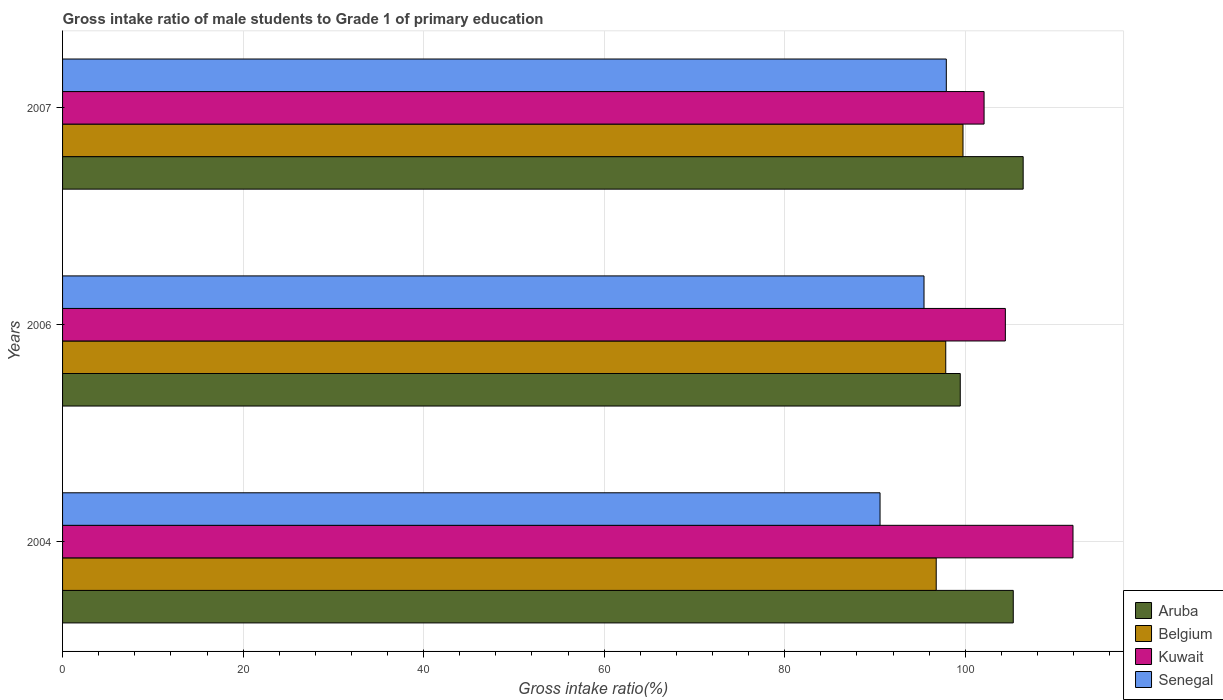How many different coloured bars are there?
Provide a short and direct response. 4. How many groups of bars are there?
Keep it short and to the point. 3. How many bars are there on the 3rd tick from the bottom?
Provide a succinct answer. 4. What is the gross intake ratio in Senegal in 2007?
Your response must be concise. 97.9. Across all years, what is the maximum gross intake ratio in Aruba?
Offer a very short reply. 106.42. Across all years, what is the minimum gross intake ratio in Kuwait?
Give a very brief answer. 102.08. In which year was the gross intake ratio in Senegal minimum?
Your answer should be very brief. 2004. What is the total gross intake ratio in Aruba in the graph?
Provide a short and direct response. 311.18. What is the difference between the gross intake ratio in Senegal in 2004 and that in 2006?
Keep it short and to the point. -4.87. What is the difference between the gross intake ratio in Aruba in 2004 and the gross intake ratio in Belgium in 2006?
Give a very brief answer. 7.48. What is the average gross intake ratio in Senegal per year?
Provide a short and direct response. 94.63. In the year 2007, what is the difference between the gross intake ratio in Kuwait and gross intake ratio in Aruba?
Your response must be concise. -4.33. In how many years, is the gross intake ratio in Aruba greater than 112 %?
Ensure brevity in your answer.  0. What is the ratio of the gross intake ratio in Kuwait in 2006 to that in 2007?
Provide a short and direct response. 1.02. Is the gross intake ratio in Aruba in 2006 less than that in 2007?
Your answer should be compact. Yes. Is the difference between the gross intake ratio in Kuwait in 2004 and 2007 greater than the difference between the gross intake ratio in Aruba in 2004 and 2007?
Keep it short and to the point. Yes. What is the difference between the highest and the second highest gross intake ratio in Senegal?
Keep it short and to the point. 2.47. What is the difference between the highest and the lowest gross intake ratio in Belgium?
Your response must be concise. 2.97. In how many years, is the gross intake ratio in Aruba greater than the average gross intake ratio in Aruba taken over all years?
Your answer should be compact. 2. Is the sum of the gross intake ratio in Kuwait in 2004 and 2006 greater than the maximum gross intake ratio in Belgium across all years?
Your answer should be compact. Yes. What does the 1st bar from the top in 2007 represents?
Your answer should be compact. Senegal. What does the 4th bar from the bottom in 2006 represents?
Keep it short and to the point. Senegal. How many legend labels are there?
Keep it short and to the point. 4. What is the title of the graph?
Your answer should be very brief. Gross intake ratio of male students to Grade 1 of primary education. Does "Latin America(developing only)" appear as one of the legend labels in the graph?
Ensure brevity in your answer.  No. What is the label or title of the X-axis?
Your answer should be compact. Gross intake ratio(%). What is the label or title of the Y-axis?
Offer a very short reply. Years. What is the Gross intake ratio(%) in Aruba in 2004?
Keep it short and to the point. 105.32. What is the Gross intake ratio(%) of Belgium in 2004?
Your response must be concise. 96.78. What is the Gross intake ratio(%) of Kuwait in 2004?
Provide a short and direct response. 111.94. What is the Gross intake ratio(%) in Senegal in 2004?
Keep it short and to the point. 90.56. What is the Gross intake ratio(%) in Aruba in 2006?
Make the answer very short. 99.45. What is the Gross intake ratio(%) of Belgium in 2006?
Provide a short and direct response. 97.84. What is the Gross intake ratio(%) in Kuwait in 2006?
Ensure brevity in your answer.  104.44. What is the Gross intake ratio(%) of Senegal in 2006?
Your answer should be very brief. 95.43. What is the Gross intake ratio(%) in Aruba in 2007?
Ensure brevity in your answer.  106.42. What is the Gross intake ratio(%) in Belgium in 2007?
Make the answer very short. 99.75. What is the Gross intake ratio(%) in Kuwait in 2007?
Make the answer very short. 102.08. What is the Gross intake ratio(%) in Senegal in 2007?
Your answer should be very brief. 97.9. Across all years, what is the maximum Gross intake ratio(%) in Aruba?
Your answer should be compact. 106.42. Across all years, what is the maximum Gross intake ratio(%) in Belgium?
Make the answer very short. 99.75. Across all years, what is the maximum Gross intake ratio(%) in Kuwait?
Provide a short and direct response. 111.94. Across all years, what is the maximum Gross intake ratio(%) of Senegal?
Offer a terse response. 97.9. Across all years, what is the minimum Gross intake ratio(%) in Aruba?
Make the answer very short. 99.45. Across all years, what is the minimum Gross intake ratio(%) in Belgium?
Offer a terse response. 96.78. Across all years, what is the minimum Gross intake ratio(%) of Kuwait?
Keep it short and to the point. 102.08. Across all years, what is the minimum Gross intake ratio(%) in Senegal?
Keep it short and to the point. 90.56. What is the total Gross intake ratio(%) in Aruba in the graph?
Make the answer very short. 311.18. What is the total Gross intake ratio(%) of Belgium in the graph?
Provide a short and direct response. 294.37. What is the total Gross intake ratio(%) in Kuwait in the graph?
Your response must be concise. 318.46. What is the total Gross intake ratio(%) in Senegal in the graph?
Provide a succinct answer. 283.89. What is the difference between the Gross intake ratio(%) of Aruba in 2004 and that in 2006?
Your answer should be compact. 5.87. What is the difference between the Gross intake ratio(%) in Belgium in 2004 and that in 2006?
Make the answer very short. -1.06. What is the difference between the Gross intake ratio(%) in Kuwait in 2004 and that in 2006?
Offer a terse response. 7.49. What is the difference between the Gross intake ratio(%) in Senegal in 2004 and that in 2006?
Ensure brevity in your answer.  -4.87. What is the difference between the Gross intake ratio(%) in Aruba in 2004 and that in 2007?
Offer a very short reply. -1.1. What is the difference between the Gross intake ratio(%) in Belgium in 2004 and that in 2007?
Provide a succinct answer. -2.97. What is the difference between the Gross intake ratio(%) in Kuwait in 2004 and that in 2007?
Offer a terse response. 9.85. What is the difference between the Gross intake ratio(%) in Senegal in 2004 and that in 2007?
Provide a short and direct response. -7.34. What is the difference between the Gross intake ratio(%) of Aruba in 2006 and that in 2007?
Provide a short and direct response. -6.97. What is the difference between the Gross intake ratio(%) in Belgium in 2006 and that in 2007?
Provide a short and direct response. -1.91. What is the difference between the Gross intake ratio(%) of Kuwait in 2006 and that in 2007?
Provide a succinct answer. 2.36. What is the difference between the Gross intake ratio(%) of Senegal in 2006 and that in 2007?
Make the answer very short. -2.47. What is the difference between the Gross intake ratio(%) in Aruba in 2004 and the Gross intake ratio(%) in Belgium in 2006?
Make the answer very short. 7.48. What is the difference between the Gross intake ratio(%) of Aruba in 2004 and the Gross intake ratio(%) of Kuwait in 2006?
Keep it short and to the point. 0.88. What is the difference between the Gross intake ratio(%) of Aruba in 2004 and the Gross intake ratio(%) of Senegal in 2006?
Provide a succinct answer. 9.89. What is the difference between the Gross intake ratio(%) in Belgium in 2004 and the Gross intake ratio(%) in Kuwait in 2006?
Offer a terse response. -7.66. What is the difference between the Gross intake ratio(%) in Belgium in 2004 and the Gross intake ratio(%) in Senegal in 2006?
Keep it short and to the point. 1.35. What is the difference between the Gross intake ratio(%) of Kuwait in 2004 and the Gross intake ratio(%) of Senegal in 2006?
Give a very brief answer. 16.51. What is the difference between the Gross intake ratio(%) of Aruba in 2004 and the Gross intake ratio(%) of Belgium in 2007?
Provide a succinct answer. 5.57. What is the difference between the Gross intake ratio(%) in Aruba in 2004 and the Gross intake ratio(%) in Kuwait in 2007?
Offer a terse response. 3.23. What is the difference between the Gross intake ratio(%) of Aruba in 2004 and the Gross intake ratio(%) of Senegal in 2007?
Your answer should be compact. 7.42. What is the difference between the Gross intake ratio(%) in Belgium in 2004 and the Gross intake ratio(%) in Kuwait in 2007?
Your answer should be very brief. -5.3. What is the difference between the Gross intake ratio(%) in Belgium in 2004 and the Gross intake ratio(%) in Senegal in 2007?
Your response must be concise. -1.12. What is the difference between the Gross intake ratio(%) of Kuwait in 2004 and the Gross intake ratio(%) of Senegal in 2007?
Ensure brevity in your answer.  14.03. What is the difference between the Gross intake ratio(%) in Aruba in 2006 and the Gross intake ratio(%) in Belgium in 2007?
Your response must be concise. -0.3. What is the difference between the Gross intake ratio(%) in Aruba in 2006 and the Gross intake ratio(%) in Kuwait in 2007?
Your response must be concise. -2.64. What is the difference between the Gross intake ratio(%) of Aruba in 2006 and the Gross intake ratio(%) of Senegal in 2007?
Ensure brevity in your answer.  1.55. What is the difference between the Gross intake ratio(%) in Belgium in 2006 and the Gross intake ratio(%) in Kuwait in 2007?
Your answer should be compact. -4.24. What is the difference between the Gross intake ratio(%) of Belgium in 2006 and the Gross intake ratio(%) of Senegal in 2007?
Provide a succinct answer. -0.06. What is the difference between the Gross intake ratio(%) in Kuwait in 2006 and the Gross intake ratio(%) in Senegal in 2007?
Provide a short and direct response. 6.54. What is the average Gross intake ratio(%) of Aruba per year?
Keep it short and to the point. 103.73. What is the average Gross intake ratio(%) in Belgium per year?
Offer a very short reply. 98.12. What is the average Gross intake ratio(%) in Kuwait per year?
Keep it short and to the point. 106.15. What is the average Gross intake ratio(%) in Senegal per year?
Offer a terse response. 94.63. In the year 2004, what is the difference between the Gross intake ratio(%) of Aruba and Gross intake ratio(%) of Belgium?
Keep it short and to the point. 8.54. In the year 2004, what is the difference between the Gross intake ratio(%) of Aruba and Gross intake ratio(%) of Kuwait?
Ensure brevity in your answer.  -6.62. In the year 2004, what is the difference between the Gross intake ratio(%) of Aruba and Gross intake ratio(%) of Senegal?
Ensure brevity in your answer.  14.76. In the year 2004, what is the difference between the Gross intake ratio(%) of Belgium and Gross intake ratio(%) of Kuwait?
Your response must be concise. -15.15. In the year 2004, what is the difference between the Gross intake ratio(%) in Belgium and Gross intake ratio(%) in Senegal?
Give a very brief answer. 6.22. In the year 2004, what is the difference between the Gross intake ratio(%) of Kuwait and Gross intake ratio(%) of Senegal?
Provide a short and direct response. 21.38. In the year 2006, what is the difference between the Gross intake ratio(%) of Aruba and Gross intake ratio(%) of Belgium?
Provide a short and direct response. 1.61. In the year 2006, what is the difference between the Gross intake ratio(%) of Aruba and Gross intake ratio(%) of Kuwait?
Offer a very short reply. -5. In the year 2006, what is the difference between the Gross intake ratio(%) in Aruba and Gross intake ratio(%) in Senegal?
Ensure brevity in your answer.  4.02. In the year 2006, what is the difference between the Gross intake ratio(%) in Belgium and Gross intake ratio(%) in Kuwait?
Provide a succinct answer. -6.6. In the year 2006, what is the difference between the Gross intake ratio(%) of Belgium and Gross intake ratio(%) of Senegal?
Provide a short and direct response. 2.41. In the year 2006, what is the difference between the Gross intake ratio(%) in Kuwait and Gross intake ratio(%) in Senegal?
Provide a succinct answer. 9.01. In the year 2007, what is the difference between the Gross intake ratio(%) of Aruba and Gross intake ratio(%) of Belgium?
Provide a succinct answer. 6.67. In the year 2007, what is the difference between the Gross intake ratio(%) of Aruba and Gross intake ratio(%) of Kuwait?
Keep it short and to the point. 4.33. In the year 2007, what is the difference between the Gross intake ratio(%) of Aruba and Gross intake ratio(%) of Senegal?
Your answer should be compact. 8.51. In the year 2007, what is the difference between the Gross intake ratio(%) of Belgium and Gross intake ratio(%) of Kuwait?
Offer a very short reply. -2.33. In the year 2007, what is the difference between the Gross intake ratio(%) in Belgium and Gross intake ratio(%) in Senegal?
Your answer should be compact. 1.85. In the year 2007, what is the difference between the Gross intake ratio(%) in Kuwait and Gross intake ratio(%) in Senegal?
Make the answer very short. 4.18. What is the ratio of the Gross intake ratio(%) of Aruba in 2004 to that in 2006?
Ensure brevity in your answer.  1.06. What is the ratio of the Gross intake ratio(%) in Kuwait in 2004 to that in 2006?
Offer a very short reply. 1.07. What is the ratio of the Gross intake ratio(%) of Senegal in 2004 to that in 2006?
Your response must be concise. 0.95. What is the ratio of the Gross intake ratio(%) of Aruba in 2004 to that in 2007?
Provide a short and direct response. 0.99. What is the ratio of the Gross intake ratio(%) of Belgium in 2004 to that in 2007?
Your response must be concise. 0.97. What is the ratio of the Gross intake ratio(%) of Kuwait in 2004 to that in 2007?
Offer a terse response. 1.1. What is the ratio of the Gross intake ratio(%) in Senegal in 2004 to that in 2007?
Your answer should be compact. 0.93. What is the ratio of the Gross intake ratio(%) of Aruba in 2006 to that in 2007?
Your response must be concise. 0.93. What is the ratio of the Gross intake ratio(%) in Belgium in 2006 to that in 2007?
Your response must be concise. 0.98. What is the ratio of the Gross intake ratio(%) of Kuwait in 2006 to that in 2007?
Keep it short and to the point. 1.02. What is the ratio of the Gross intake ratio(%) in Senegal in 2006 to that in 2007?
Keep it short and to the point. 0.97. What is the difference between the highest and the second highest Gross intake ratio(%) of Aruba?
Provide a succinct answer. 1.1. What is the difference between the highest and the second highest Gross intake ratio(%) of Belgium?
Your answer should be compact. 1.91. What is the difference between the highest and the second highest Gross intake ratio(%) of Kuwait?
Your answer should be compact. 7.49. What is the difference between the highest and the second highest Gross intake ratio(%) of Senegal?
Your answer should be very brief. 2.47. What is the difference between the highest and the lowest Gross intake ratio(%) in Aruba?
Your answer should be very brief. 6.97. What is the difference between the highest and the lowest Gross intake ratio(%) of Belgium?
Provide a succinct answer. 2.97. What is the difference between the highest and the lowest Gross intake ratio(%) in Kuwait?
Provide a short and direct response. 9.85. What is the difference between the highest and the lowest Gross intake ratio(%) of Senegal?
Offer a terse response. 7.34. 